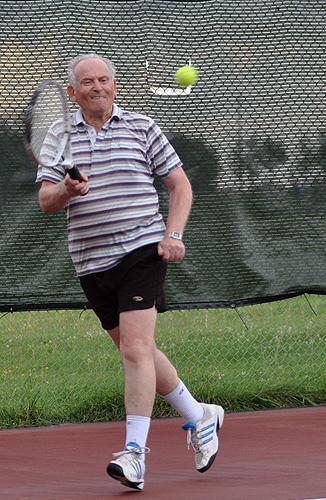What color is the tennis ball?
Keep it brief. Yellow. Which wrist wears a watch?
Concise answer only. Left. Is the man swinging the tennis racket, or is it stationary?
Answer briefly. Swinging. 